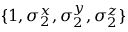<formula> <loc_0><loc_0><loc_500><loc_500>\{ 1 , \sigma _ { 2 } ^ { x } , \sigma _ { 2 } ^ { y } , \sigma _ { 2 } ^ { z } \}</formula> 